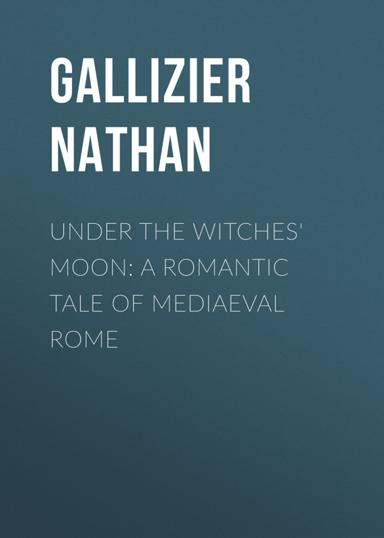Can you describe the main plot or theme of "Under the Witches' Moon"? Certainly! "Under the Witches' Moon" is a romantic novel that intertwines themes of love, destiny, and magic within the historical context of medieval Rome. The story captures the entangling lives of characters touched by mystical destinies in a time of political upheaval and personal discovery. 